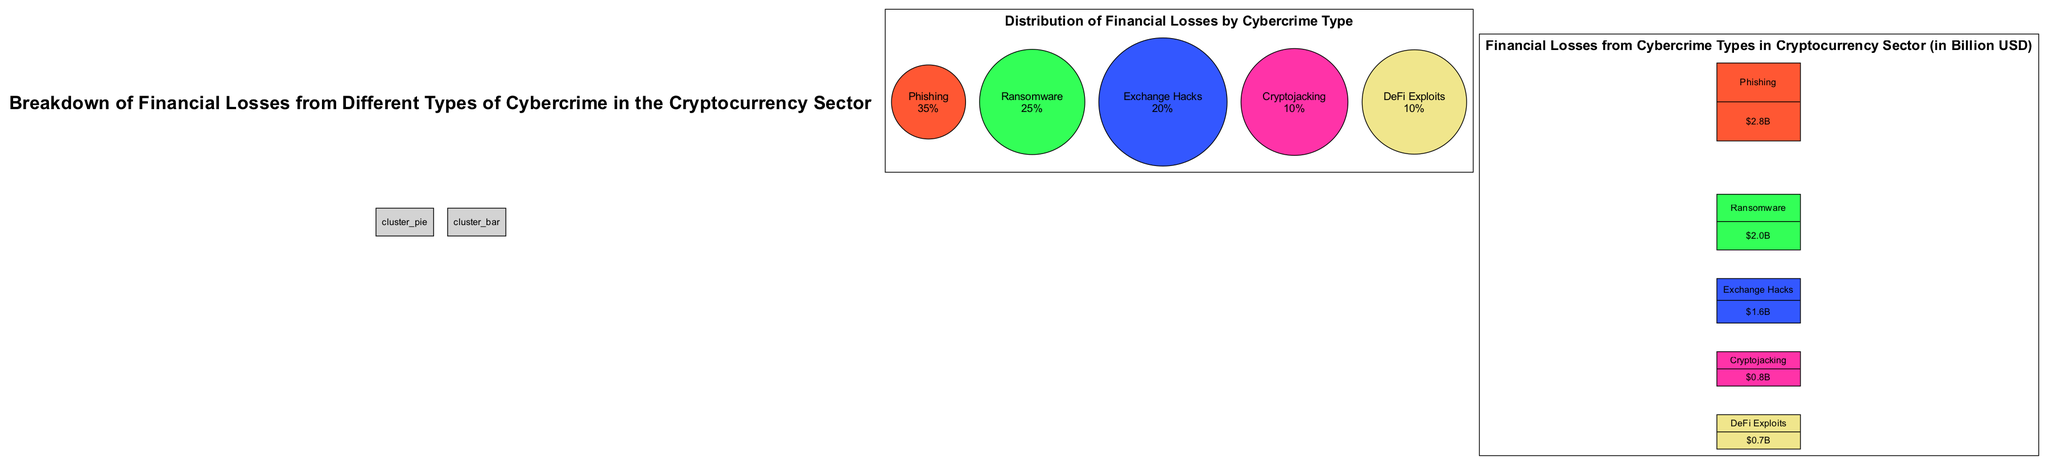What's the percentage of financial losses attributed to phishing? The diagram's pie chart indicates that phishing accounts for 35% of the financial losses from cybercrime in the cryptocurrency sector.
Answer: 35% How much financial loss is associated with ransomware in billion USD? The bar chart shows that ransomware has caused financial losses amounting to 2.0 billion USD.
Answer: 2.0 billion USD Which type of cybercrime results in the least financial loss? Examining the bar chart, DeFi exploits, with a loss of 0.7 billion USD, is the lowest among the listed cybercrime types.
Answer: DeFi exploits What is the combined percentage of financial losses from cryptojacking and DeFi exploits? By adding the percentages from the pie chart, cryptojacking (10%) and DeFi exploits (10%) total 20%.
Answer: 20% What is the total financial loss from phishing and exchange hacks in billion USD? Adding the values in the bar chart, phishing (2.8 billion USD) and exchange hacks (1.6 billion USD) result in a total loss of 4.4 billion USD.
Answer: 4.4 billion USD Which type of cybercrime contributes to a greater financial loss: exchange hacks or ransomware? The bar chart shows ransomware losses at 2.0 billion USD and exchange hacks at 1.6 billion USD, indicating ransomware has a greater impact.
Answer: Ransomware What is the color associated with the segment for phishing in the pie chart? The pie chart segment for phishing is colored in a bright orange hue represented by the color code #FF5733.
Answer: #FF5733 How does the loss from cryptojacking compare to that from ransomware in terms of financial impact? The bar chart shows that cryptojacking incurred losses of 0.8 billion USD, significantly less than ransomware's 2.0 billion USD, illustrating a much lower financial impact.
Answer: Less Which chart type is used to present the breakdown of financial losses among different cybercrime types? The diagram includes both pie charts and bar graphs to display the financial loss breakdown. The pie chart shows the distribution, while the bar chart presents specific financial values.
Answer: Pie chart and bar graph 